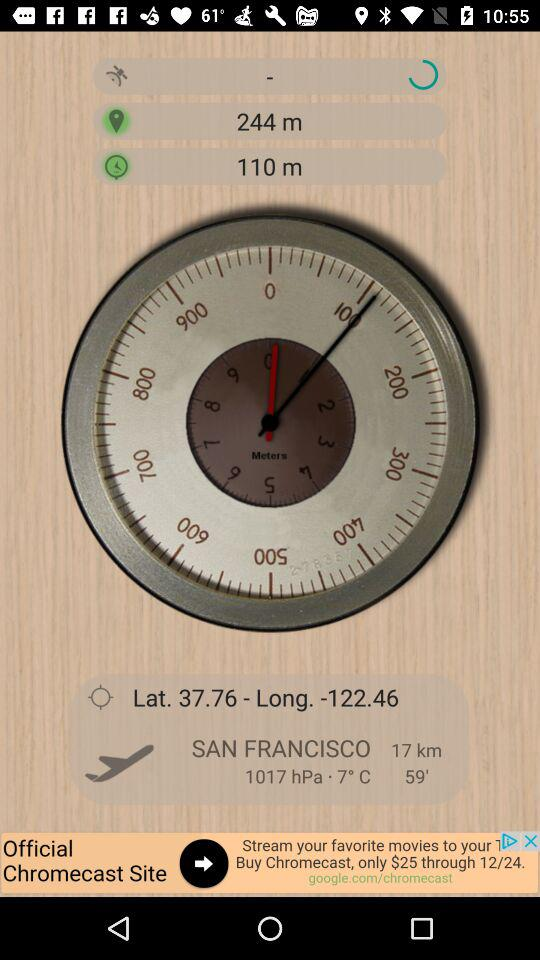What is the latitude value? The latitude value is 37.76. 